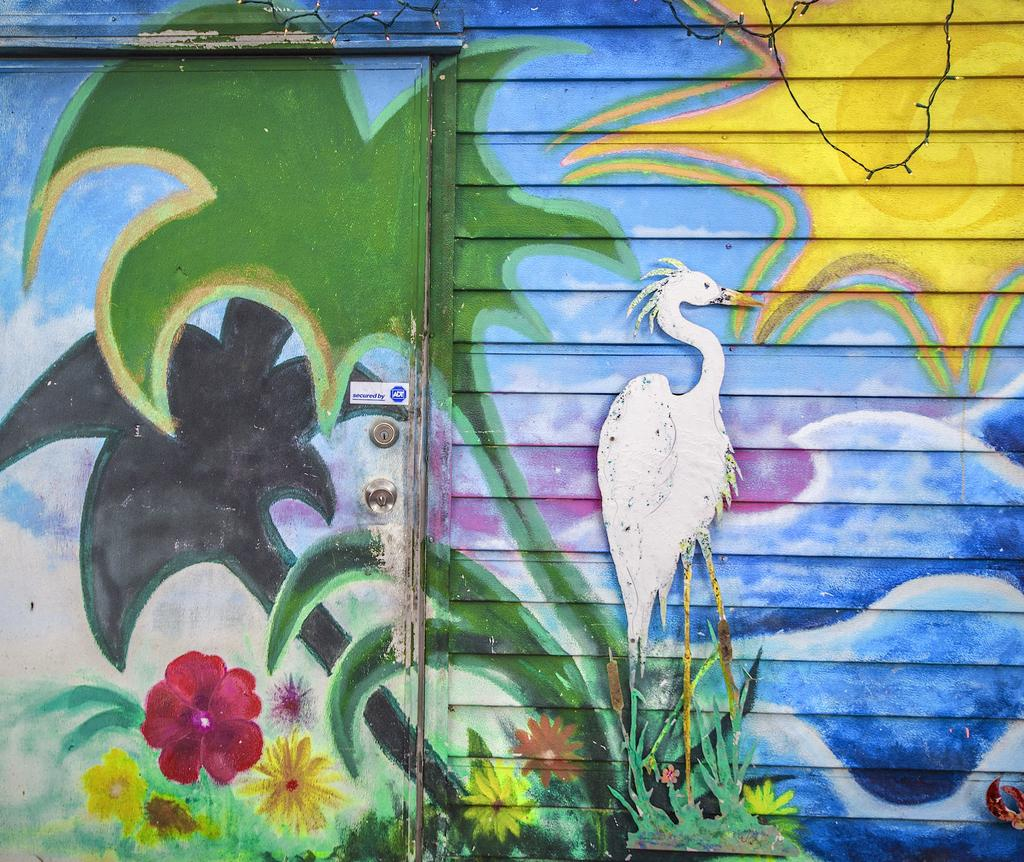What are the main architectural features in the image? The image contains a wall and a door. What type of artwork is present in the image? There is a painting in the image. What is depicted in the painting? The painting includes trees, flowers, a crane, water, a sun, and a cloudy sky. Where is the door located in the image? The door is on the left side of the image. How does the stranger react to the door in the image? There is no stranger present in the image, so it is not possible to determine their reaction to the door. 